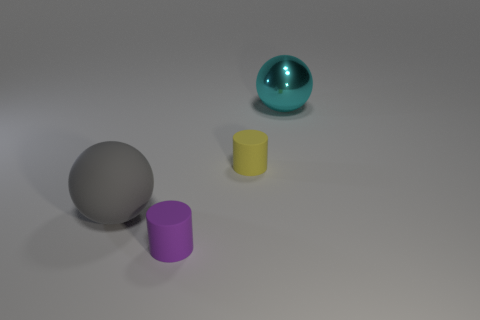Add 2 small gray shiny things. How many objects exist? 6 Subtract 0 yellow cubes. How many objects are left? 4 Subtract all tiny blue matte spheres. Subtract all large rubber things. How many objects are left? 3 Add 2 matte cylinders. How many matte cylinders are left? 4 Add 3 yellow rubber balls. How many yellow rubber balls exist? 3 